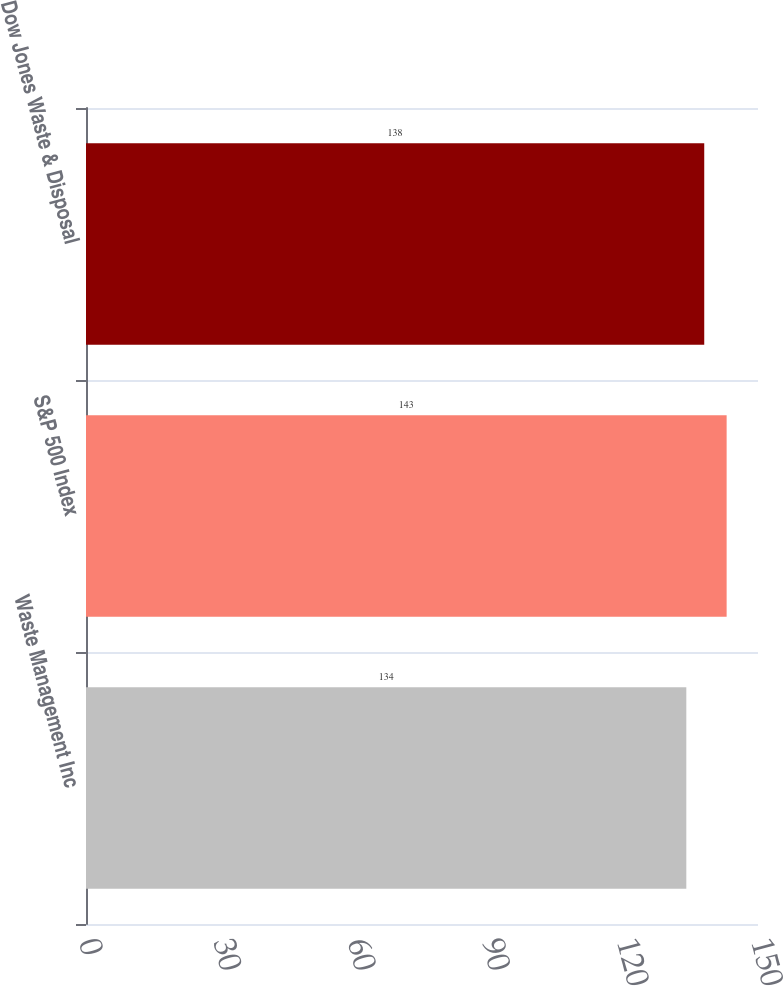Convert chart to OTSL. <chart><loc_0><loc_0><loc_500><loc_500><bar_chart><fcel>Waste Management Inc<fcel>S&P 500 Index<fcel>Dow Jones Waste & Disposal<nl><fcel>134<fcel>143<fcel>138<nl></chart> 